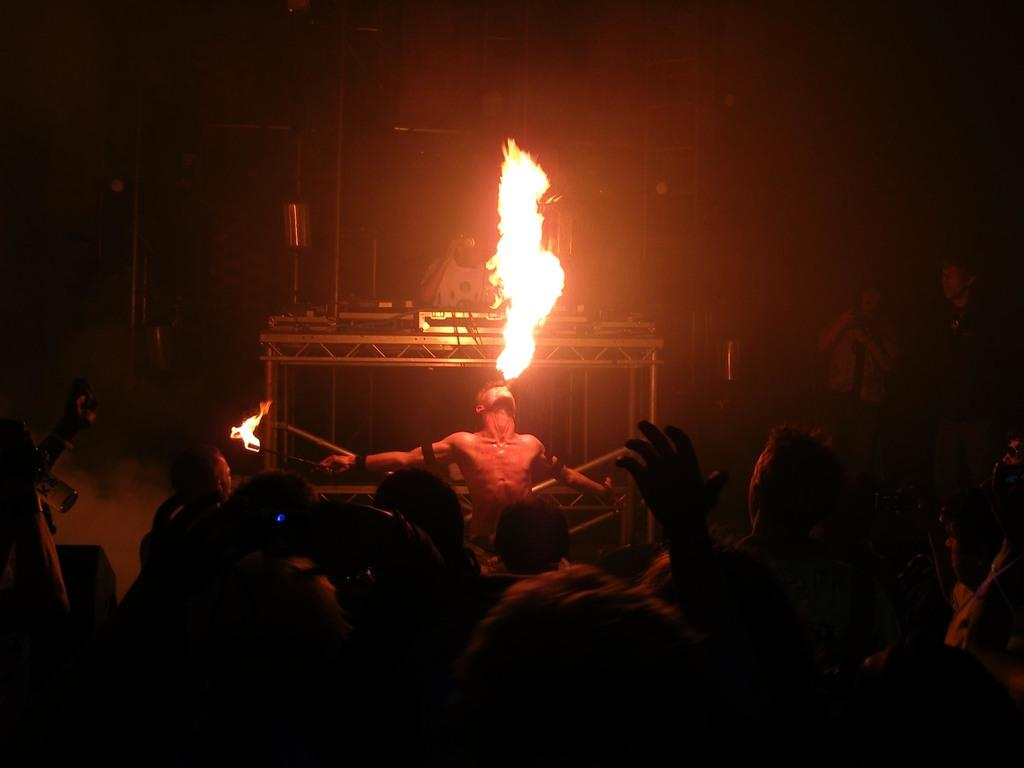What is the man in the image doing? The man in the image is blowing fire. What can be seen in the background of the image? There is an iron grill visible in the background of the image. What are the other persons in the image doing? The persons standing on the ground in the image are likely observing the man blowing fire. What type of wood is being used to cook the rice in the image? There is no wood or rice present in the image; it features a man blowing fire and an iron grill in the background. How many cards are being held by the person in the image? There are no cards or persons holding cards present in the image. 